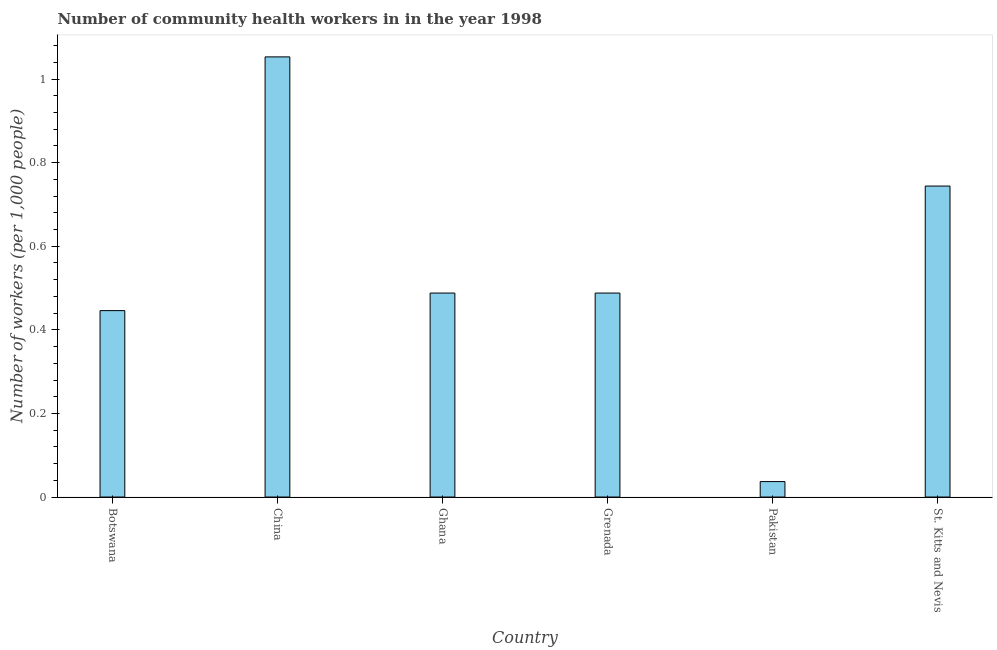Does the graph contain any zero values?
Offer a terse response. No. Does the graph contain grids?
Ensure brevity in your answer.  No. What is the title of the graph?
Give a very brief answer. Number of community health workers in in the year 1998. What is the label or title of the Y-axis?
Your response must be concise. Number of workers (per 1,0 people). What is the number of community health workers in St. Kitts and Nevis?
Offer a terse response. 0.74. Across all countries, what is the maximum number of community health workers?
Keep it short and to the point. 1.05. Across all countries, what is the minimum number of community health workers?
Provide a short and direct response. 0.04. What is the sum of the number of community health workers?
Provide a short and direct response. 3.26. What is the difference between the number of community health workers in Botswana and Ghana?
Provide a succinct answer. -0.04. What is the average number of community health workers per country?
Your response must be concise. 0.54. What is the median number of community health workers?
Give a very brief answer. 0.49. What is the ratio of the number of community health workers in Grenada to that in Pakistan?
Offer a very short reply. 13.19. Is the number of community health workers in Ghana less than that in Pakistan?
Your answer should be compact. No. Is the difference between the number of community health workers in Botswana and Grenada greater than the difference between any two countries?
Make the answer very short. No. What is the difference between the highest and the second highest number of community health workers?
Offer a terse response. 0.31. Is the sum of the number of community health workers in Botswana and China greater than the maximum number of community health workers across all countries?
Your answer should be very brief. Yes. What is the difference between the highest and the lowest number of community health workers?
Offer a terse response. 1.02. How many bars are there?
Your answer should be very brief. 6. Are all the bars in the graph horizontal?
Provide a succinct answer. No. What is the difference between two consecutive major ticks on the Y-axis?
Keep it short and to the point. 0.2. Are the values on the major ticks of Y-axis written in scientific E-notation?
Make the answer very short. No. What is the Number of workers (per 1,000 people) in Botswana?
Your answer should be compact. 0.45. What is the Number of workers (per 1,000 people) of China?
Keep it short and to the point. 1.05. What is the Number of workers (per 1,000 people) in Ghana?
Ensure brevity in your answer.  0.49. What is the Number of workers (per 1,000 people) of Grenada?
Your answer should be compact. 0.49. What is the Number of workers (per 1,000 people) of Pakistan?
Give a very brief answer. 0.04. What is the Number of workers (per 1,000 people) of St. Kitts and Nevis?
Your response must be concise. 0.74. What is the difference between the Number of workers (per 1,000 people) in Botswana and China?
Give a very brief answer. -0.61. What is the difference between the Number of workers (per 1,000 people) in Botswana and Ghana?
Make the answer very short. -0.04. What is the difference between the Number of workers (per 1,000 people) in Botswana and Grenada?
Make the answer very short. -0.04. What is the difference between the Number of workers (per 1,000 people) in Botswana and Pakistan?
Provide a succinct answer. 0.41. What is the difference between the Number of workers (per 1,000 people) in Botswana and St. Kitts and Nevis?
Provide a short and direct response. -0.3. What is the difference between the Number of workers (per 1,000 people) in China and Ghana?
Provide a succinct answer. 0.56. What is the difference between the Number of workers (per 1,000 people) in China and Grenada?
Ensure brevity in your answer.  0.56. What is the difference between the Number of workers (per 1,000 people) in China and Pakistan?
Make the answer very short. 1.02. What is the difference between the Number of workers (per 1,000 people) in China and St. Kitts and Nevis?
Your answer should be compact. 0.31. What is the difference between the Number of workers (per 1,000 people) in Ghana and Pakistan?
Your response must be concise. 0.45. What is the difference between the Number of workers (per 1,000 people) in Ghana and St. Kitts and Nevis?
Your answer should be compact. -0.26. What is the difference between the Number of workers (per 1,000 people) in Grenada and Pakistan?
Your answer should be very brief. 0.45. What is the difference between the Number of workers (per 1,000 people) in Grenada and St. Kitts and Nevis?
Provide a short and direct response. -0.26. What is the difference between the Number of workers (per 1,000 people) in Pakistan and St. Kitts and Nevis?
Keep it short and to the point. -0.71. What is the ratio of the Number of workers (per 1,000 people) in Botswana to that in China?
Ensure brevity in your answer.  0.42. What is the ratio of the Number of workers (per 1,000 people) in Botswana to that in Ghana?
Offer a very short reply. 0.91. What is the ratio of the Number of workers (per 1,000 people) in Botswana to that in Grenada?
Your response must be concise. 0.91. What is the ratio of the Number of workers (per 1,000 people) in Botswana to that in Pakistan?
Ensure brevity in your answer.  12.05. What is the ratio of the Number of workers (per 1,000 people) in Botswana to that in St. Kitts and Nevis?
Your response must be concise. 0.6. What is the ratio of the Number of workers (per 1,000 people) in China to that in Ghana?
Your response must be concise. 2.16. What is the ratio of the Number of workers (per 1,000 people) in China to that in Grenada?
Your answer should be compact. 2.16. What is the ratio of the Number of workers (per 1,000 people) in China to that in Pakistan?
Provide a short and direct response. 28.46. What is the ratio of the Number of workers (per 1,000 people) in China to that in St. Kitts and Nevis?
Provide a short and direct response. 1.42. What is the ratio of the Number of workers (per 1,000 people) in Ghana to that in Grenada?
Offer a terse response. 1. What is the ratio of the Number of workers (per 1,000 people) in Ghana to that in Pakistan?
Keep it short and to the point. 13.19. What is the ratio of the Number of workers (per 1,000 people) in Ghana to that in St. Kitts and Nevis?
Provide a succinct answer. 0.66. What is the ratio of the Number of workers (per 1,000 people) in Grenada to that in Pakistan?
Offer a very short reply. 13.19. What is the ratio of the Number of workers (per 1,000 people) in Grenada to that in St. Kitts and Nevis?
Keep it short and to the point. 0.66. 